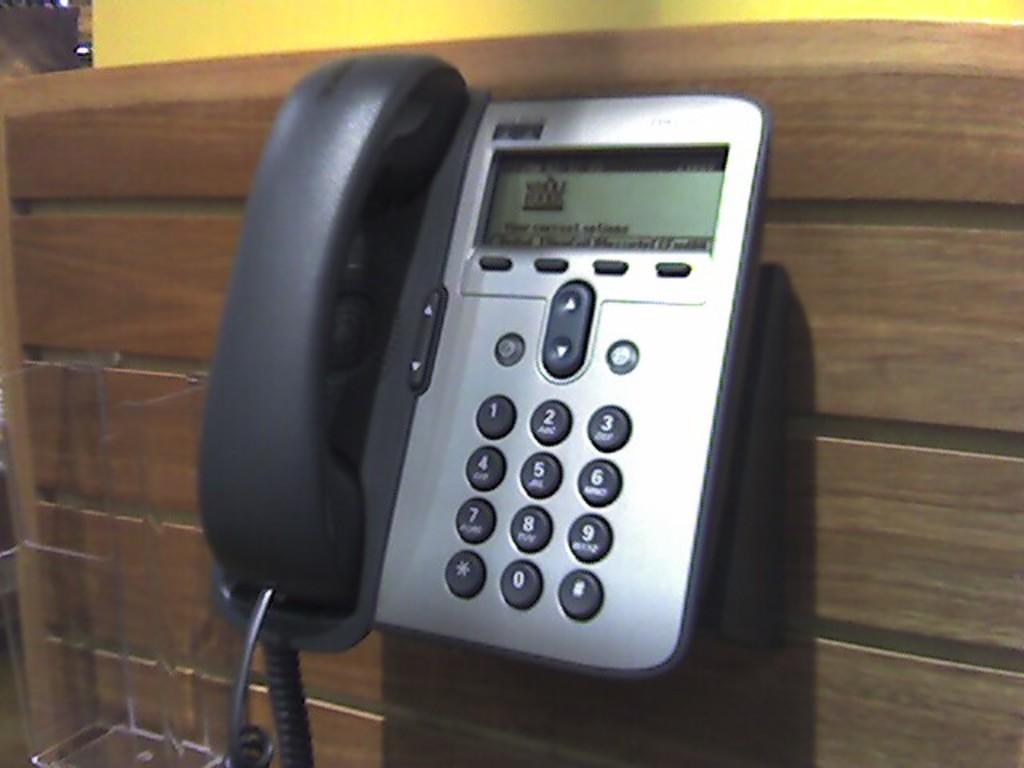Please provide a concise description of this image. In this picture there is a black and silver color telephone, hang on the wooden wall. 